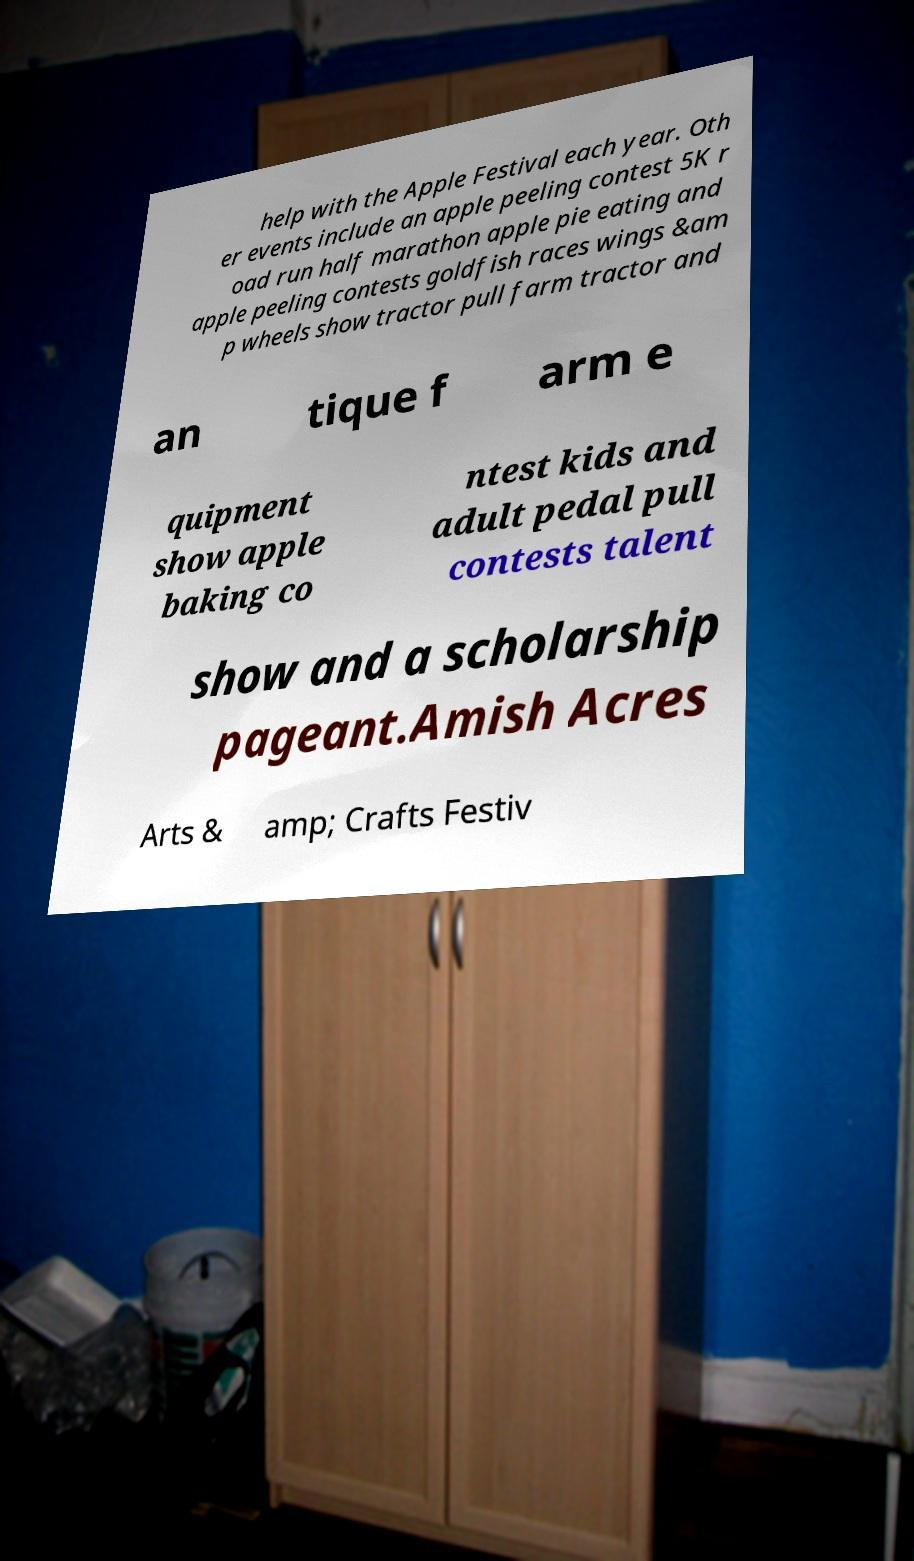For documentation purposes, I need the text within this image transcribed. Could you provide that? help with the Apple Festival each year. Oth er events include an apple peeling contest 5K r oad run half marathon apple pie eating and apple peeling contests goldfish races wings &am p wheels show tractor pull farm tractor and an tique f arm e quipment show apple baking co ntest kids and adult pedal pull contests talent show and a scholarship pageant.Amish Acres Arts & amp; Crafts Festiv 